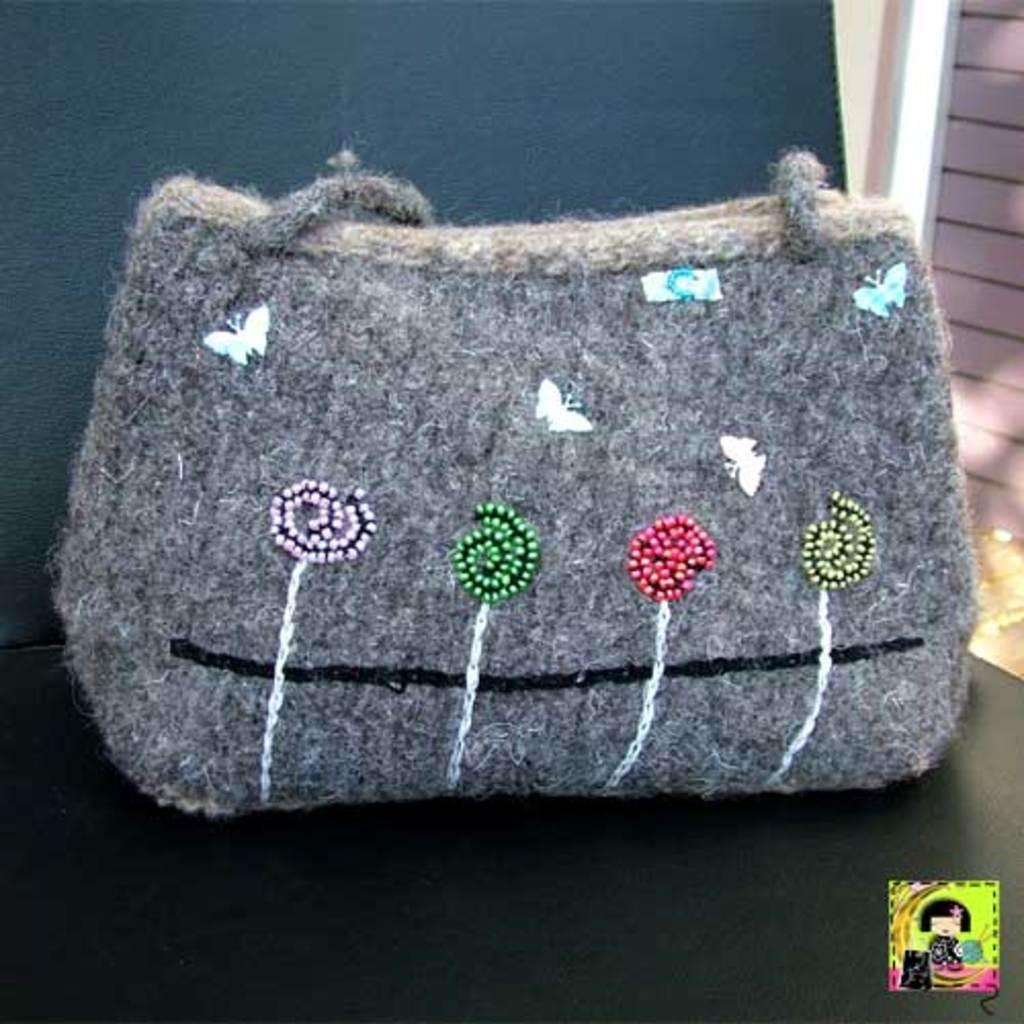What object is present in the image? There is a bag in the image. Can you describe the color of the bag? The bag is grey in color. How many cars are parked next to the bag in the image? There are no cars present in the image. What type of bucket is visible next to the bag in the image? There is no bucket present in the image. 